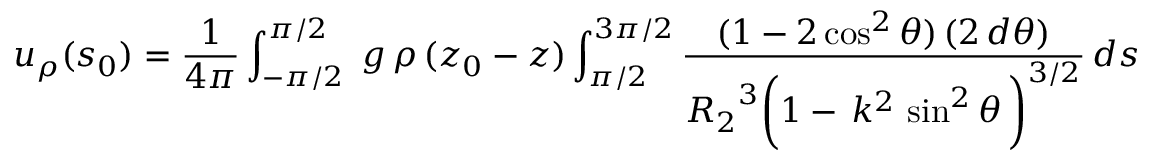Convert formula to latex. <formula><loc_0><loc_0><loc_500><loc_500>u _ { \rho } ( s _ { 0 } ) = \frac { 1 } { 4 \pi } \int _ { - \pi / 2 } ^ { \pi / 2 } \, g \, \rho \, ( z _ { 0 } - z ) \int _ { \pi / 2 } ^ { 3 \pi / 2 } \frac { ( 1 - 2 \cos ^ { 2 } \theta ) \, ( 2 \, d \theta ) } { { R _ { 2 } } ^ { 3 } \left ( 1 - \, k ^ { 2 } \, \sin ^ { 2 } \theta \, \right ) ^ { 3 / 2 } } \, d s</formula> 